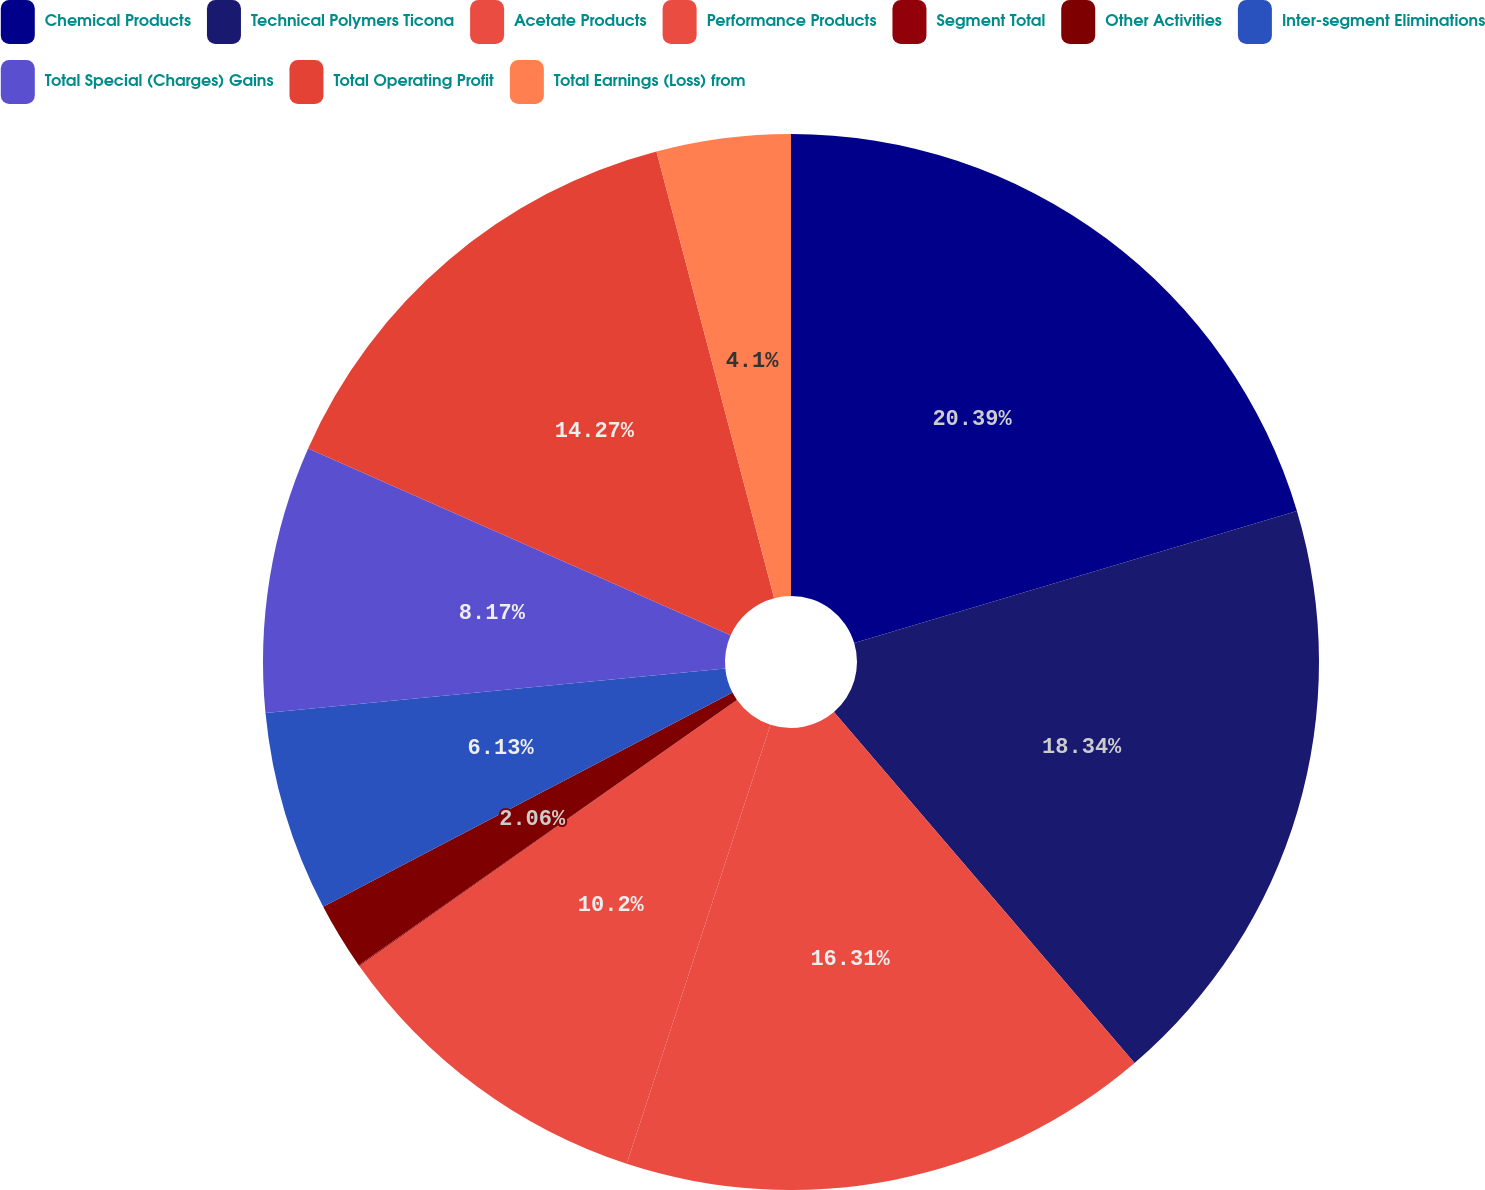Convert chart. <chart><loc_0><loc_0><loc_500><loc_500><pie_chart><fcel>Chemical Products<fcel>Technical Polymers Ticona<fcel>Acetate Products<fcel>Performance Products<fcel>Segment Total<fcel>Other Activities<fcel>Inter-segment Eliminations<fcel>Total Special (Charges) Gains<fcel>Total Operating Profit<fcel>Total Earnings (Loss) from<nl><fcel>20.38%<fcel>18.34%<fcel>16.31%<fcel>10.2%<fcel>0.03%<fcel>2.06%<fcel>6.13%<fcel>8.17%<fcel>14.27%<fcel>4.1%<nl></chart> 